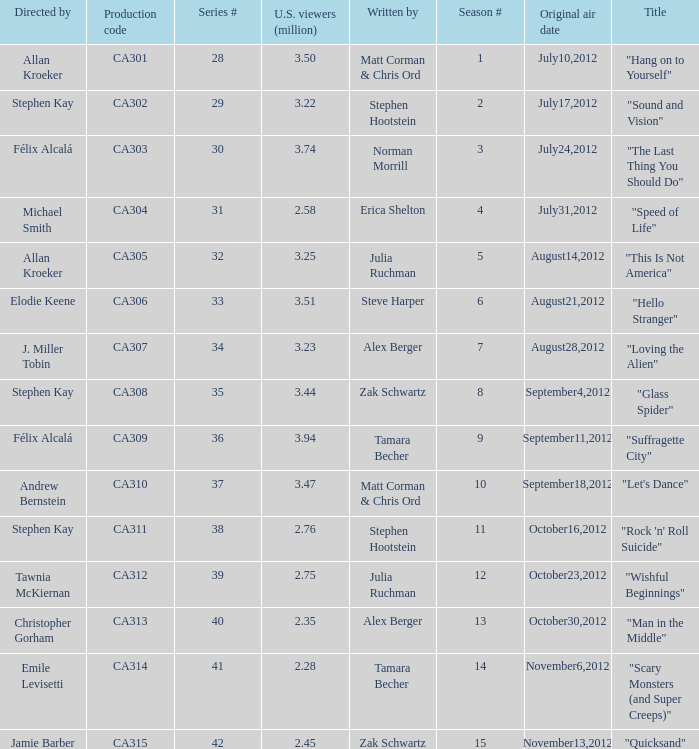What is the series episode number of the episode titled "sound and vision"? 29.0. 